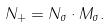Convert formula to latex. <formula><loc_0><loc_0><loc_500><loc_500>N _ { + } = N _ { \sigma } \cdot M _ { \sigma } .</formula> 